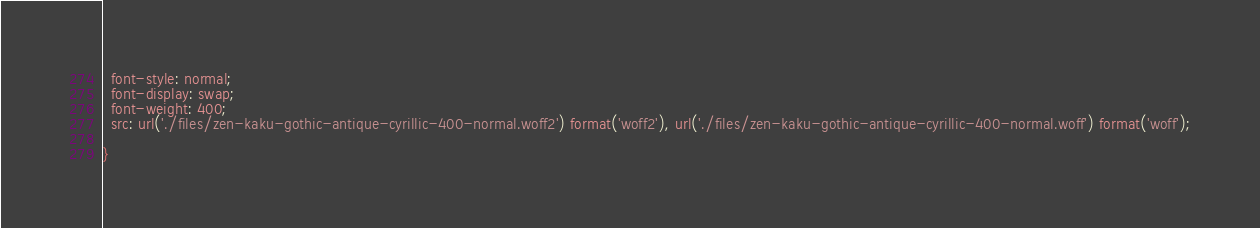<code> <loc_0><loc_0><loc_500><loc_500><_CSS_>  font-style: normal;
  font-display: swap;
  font-weight: 400;
  src: url('./files/zen-kaku-gothic-antique-cyrillic-400-normal.woff2') format('woff2'), url('./files/zen-kaku-gothic-antique-cyrillic-400-normal.woff') format('woff');
  
}
</code> 